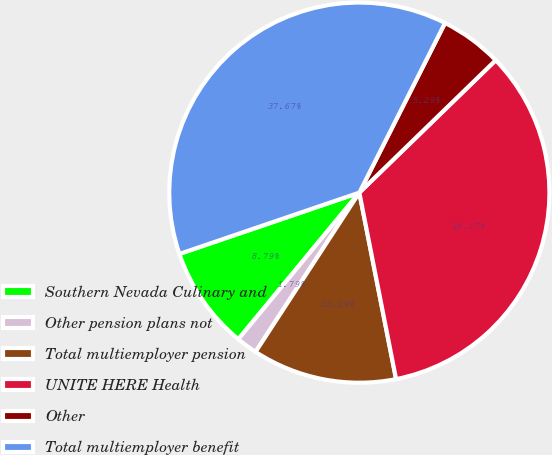<chart> <loc_0><loc_0><loc_500><loc_500><pie_chart><fcel>Southern Nevada Culinary and<fcel>Other pension plans not<fcel>Total multiemployer pension<fcel>UNITE HERE Health<fcel>Other<fcel>Total multiemployer benefit<nl><fcel>8.79%<fcel>1.79%<fcel>12.29%<fcel>34.17%<fcel>5.29%<fcel>37.67%<nl></chart> 